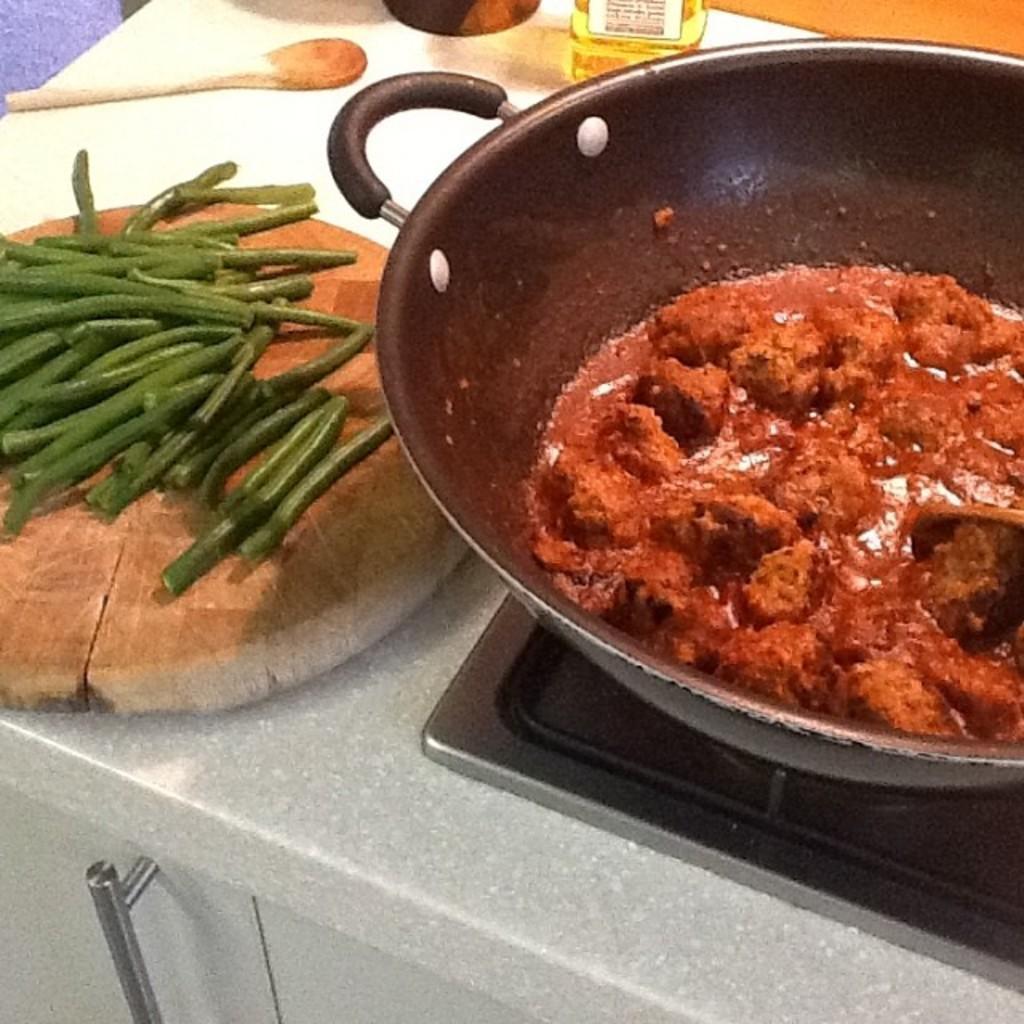Could you give a brief overview of what you see in this image? In this image we can see countertop, stove and a food item in a dish. On the left side of the image, we can see green beans on the wooden object. At the top of the image, we can see a spoon and some objects. 